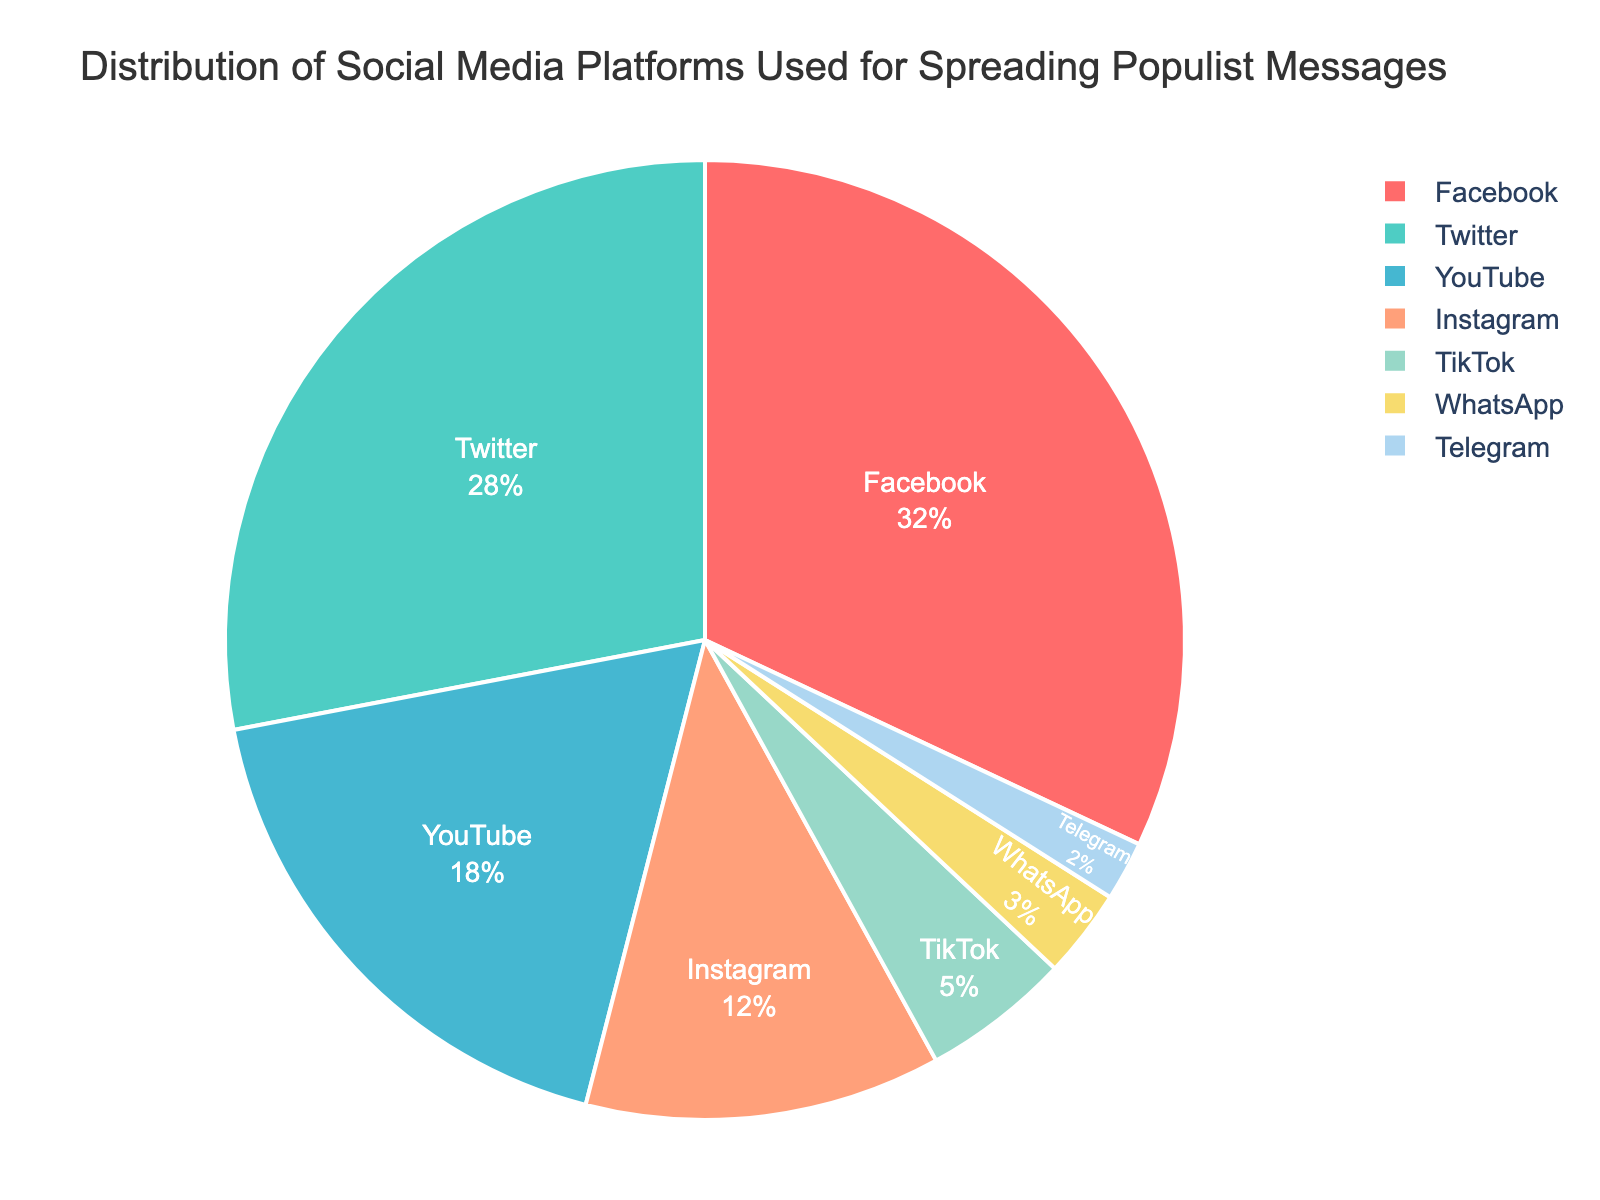What percentage of the total is comprised by Facebook and Twitter combined? Add the percentage values for Facebook (32%) and Twitter (28%). The sum is 32% + 28% = 60%.
Answer: 60% Which platform has the smallest share in the distribution? Observe the platform with the smallest percentage value. Telegram has 2%, which is the smallest.
Answer: Telegram How much larger is Facebook's share compared to Instagram's? Subtract Instagram's percentage (12%) from Facebook's percentage (32%). The difference is 32% - 12% = 20%.
Answer: 20% Arrange the platforms in descending order of their percentages. List the platforms starting from the one with the highest percentage to the lowest: Facebook (32%), Twitter (28%), YouTube (18%), Instagram (12%), TikTok (5%), WhatsApp (3%), Telegram (2%).
Answer: Facebook, Twitter, YouTube, Instagram, TikTok, WhatsApp, Telegram What is the combined percentage of YouTube, TikTok, and Telegram? Add the percentage values for YouTube (18%), TikTok (5%), and Telegram (2%). The total is 18% + 5% + 2% = 25%.
Answer: 25% Which platforms together make up more than half of the total distribution? Consider platforms from the highest percentage downward until their total exceeds 50%. Facebook (32%) and Twitter (28%) together make 32% + 28% = 60%, which is more than half.
Answer: Facebook and Twitter What percentage of the total is comprised by TikTok and WhatsApp combined? Add the percentage values for TikTok (5%) and WhatsApp (3%). The sum is 5% + 3% = 8%.
Answer: 8% Which platform has the second largest share in the distribution? Identify the platform with the second highest percentage value. Twitter has the second largest share with 28%.
Answer: Twitter 